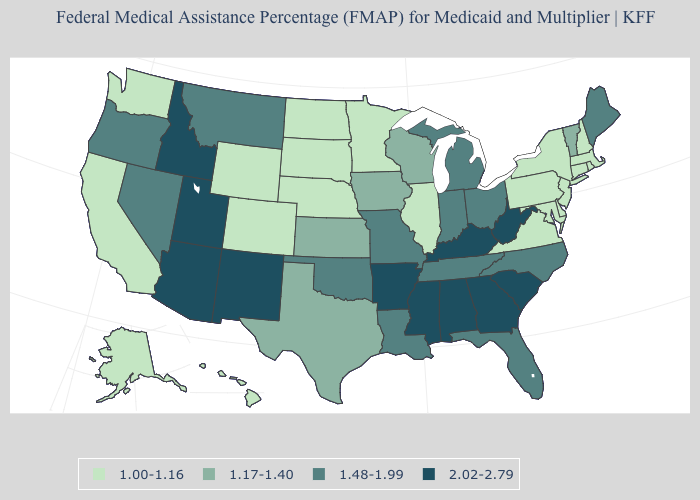Does Kentucky have a higher value than Illinois?
Be succinct. Yes. Which states have the highest value in the USA?
Write a very short answer. Alabama, Arizona, Arkansas, Georgia, Idaho, Kentucky, Mississippi, New Mexico, South Carolina, Utah, West Virginia. What is the lowest value in the USA?
Keep it brief. 1.00-1.16. Does the map have missing data?
Answer briefly. No. Name the states that have a value in the range 2.02-2.79?
Quick response, please. Alabama, Arizona, Arkansas, Georgia, Idaho, Kentucky, Mississippi, New Mexico, South Carolina, Utah, West Virginia. Does the map have missing data?
Answer briefly. No. What is the value of Tennessee?
Short answer required. 1.48-1.99. Which states have the highest value in the USA?
Be succinct. Alabama, Arizona, Arkansas, Georgia, Idaho, Kentucky, Mississippi, New Mexico, South Carolina, Utah, West Virginia. Does the first symbol in the legend represent the smallest category?
Answer briefly. Yes. What is the lowest value in states that border West Virginia?
Short answer required. 1.00-1.16. Does the map have missing data?
Write a very short answer. No. Does California have a lower value than Minnesota?
Quick response, please. No. Name the states that have a value in the range 2.02-2.79?
Write a very short answer. Alabama, Arizona, Arkansas, Georgia, Idaho, Kentucky, Mississippi, New Mexico, South Carolina, Utah, West Virginia. Does New Jersey have the same value as Colorado?
Keep it brief. Yes. Does Rhode Island have the highest value in the Northeast?
Write a very short answer. No. 